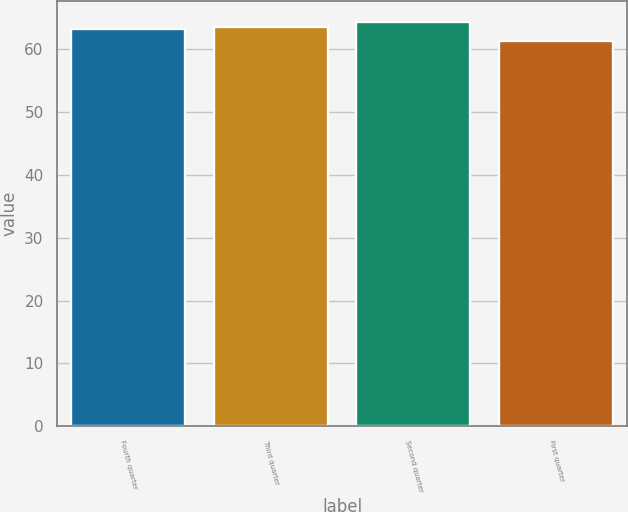<chart> <loc_0><loc_0><loc_500><loc_500><bar_chart><fcel>Fourth quarter<fcel>Third quarter<fcel>Second quarter<fcel>First quarter<nl><fcel>63.34<fcel>63.65<fcel>64.43<fcel>61.29<nl></chart> 